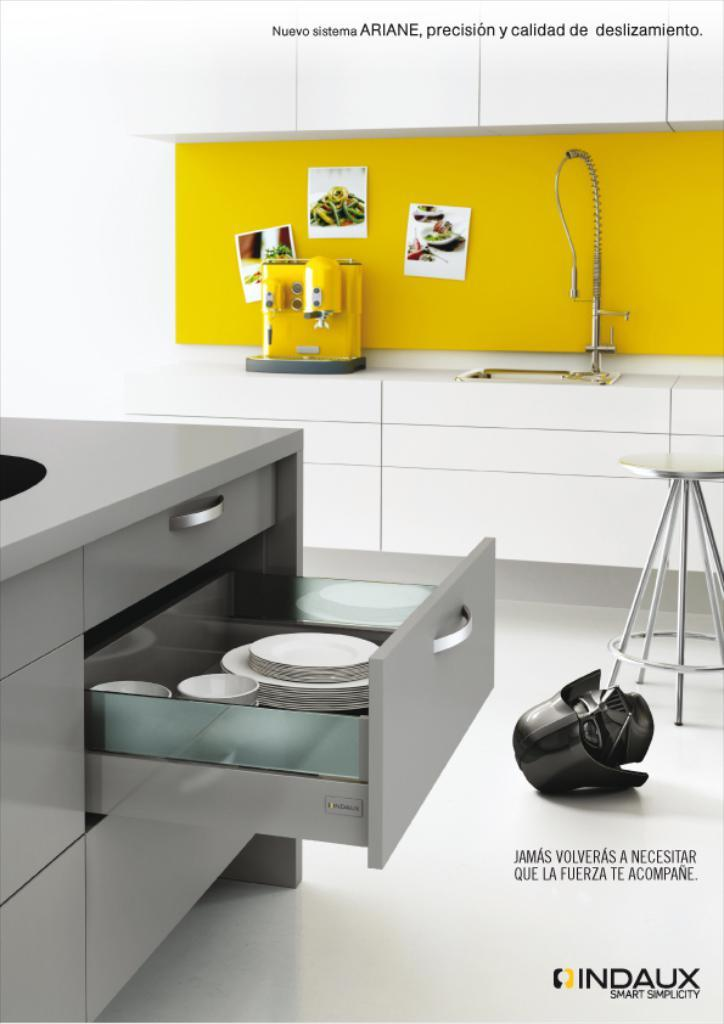<image>
Share a concise interpretation of the image provided. An advertisement for a kitchen by Indaux Smart Simplicity is shown. 